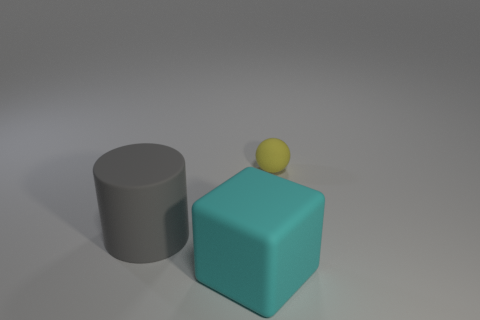Add 2 cyan blocks. How many objects exist? 5 Subtract all cubes. How many objects are left? 2 Add 2 green rubber cubes. How many green rubber cubes exist? 2 Subtract 0 red blocks. How many objects are left? 3 Subtract all big gray cylinders. Subtract all blocks. How many objects are left? 1 Add 3 tiny yellow matte spheres. How many tiny yellow matte spheres are left? 4 